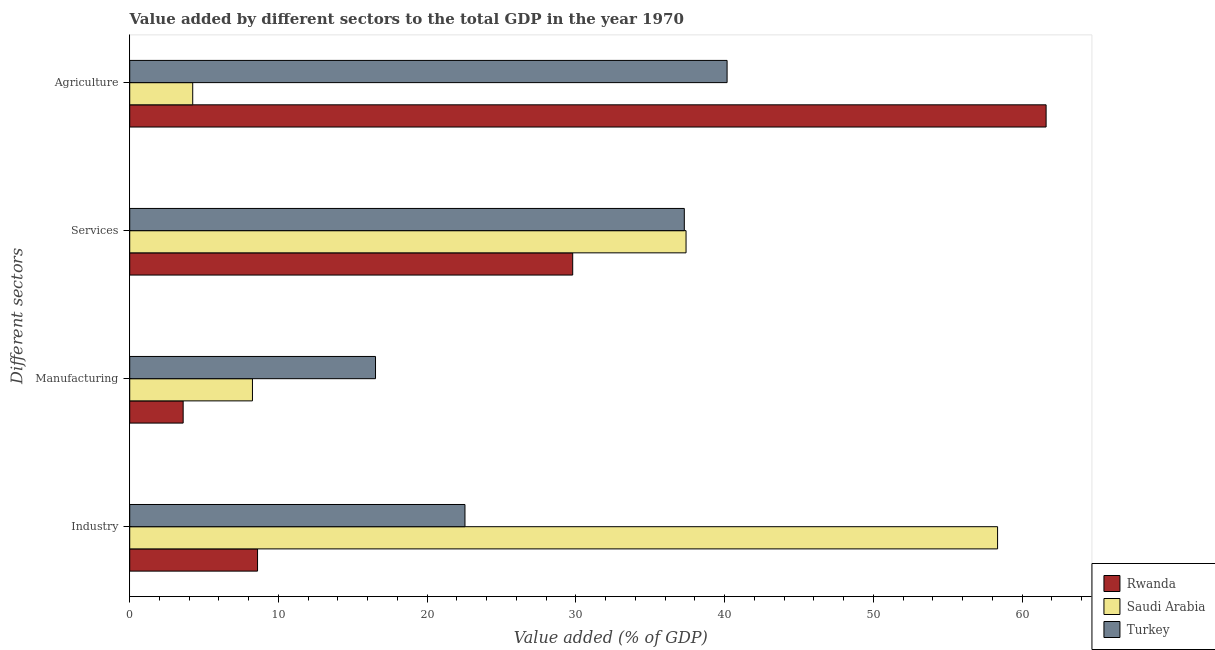How many different coloured bars are there?
Provide a succinct answer. 3. Are the number of bars per tick equal to the number of legend labels?
Make the answer very short. Yes. How many bars are there on the 1st tick from the top?
Provide a short and direct response. 3. What is the label of the 4th group of bars from the top?
Make the answer very short. Industry. What is the value added by industrial sector in Saudi Arabia?
Offer a terse response. 58.36. Across all countries, what is the maximum value added by agricultural sector?
Keep it short and to the point. 61.62. Across all countries, what is the minimum value added by agricultural sector?
Offer a terse response. 4.24. In which country was the value added by industrial sector maximum?
Give a very brief answer. Saudi Arabia. In which country was the value added by industrial sector minimum?
Make the answer very short. Rwanda. What is the total value added by agricultural sector in the graph?
Give a very brief answer. 106.02. What is the difference between the value added by agricultural sector in Turkey and that in Rwanda?
Your response must be concise. -21.45. What is the difference between the value added by manufacturing sector in Rwanda and the value added by industrial sector in Turkey?
Provide a succinct answer. -18.95. What is the average value added by agricultural sector per country?
Your response must be concise. 35.34. What is the difference between the value added by manufacturing sector and value added by agricultural sector in Turkey?
Your answer should be very brief. -23.64. In how many countries, is the value added by agricultural sector greater than 34 %?
Provide a succinct answer. 2. What is the ratio of the value added by industrial sector in Saudi Arabia to that in Turkey?
Offer a very short reply. 2.59. Is the value added by agricultural sector in Saudi Arabia less than that in Turkey?
Your answer should be very brief. Yes. Is the difference between the value added by industrial sector in Saudi Arabia and Rwanda greater than the difference between the value added by agricultural sector in Saudi Arabia and Rwanda?
Keep it short and to the point. Yes. What is the difference between the highest and the second highest value added by agricultural sector?
Keep it short and to the point. 21.45. What is the difference between the highest and the lowest value added by services sector?
Ensure brevity in your answer.  7.62. Is the sum of the value added by agricultural sector in Saudi Arabia and Turkey greater than the maximum value added by manufacturing sector across all countries?
Make the answer very short. Yes. Is it the case that in every country, the sum of the value added by services sector and value added by manufacturing sector is greater than the sum of value added by industrial sector and value added by agricultural sector?
Offer a terse response. No. What does the 3rd bar from the top in Industry represents?
Your answer should be compact. Rwanda. What does the 1st bar from the bottom in Agriculture represents?
Provide a short and direct response. Rwanda. Is it the case that in every country, the sum of the value added by industrial sector and value added by manufacturing sector is greater than the value added by services sector?
Keep it short and to the point. No. How many bars are there?
Make the answer very short. 12. Are the values on the major ticks of X-axis written in scientific E-notation?
Give a very brief answer. No. Does the graph contain grids?
Keep it short and to the point. No. Where does the legend appear in the graph?
Offer a very short reply. Bottom right. What is the title of the graph?
Your answer should be very brief. Value added by different sectors to the total GDP in the year 1970. What is the label or title of the X-axis?
Your response must be concise. Value added (% of GDP). What is the label or title of the Y-axis?
Provide a short and direct response. Different sectors. What is the Value added (% of GDP) in Rwanda in Industry?
Keep it short and to the point. 8.59. What is the Value added (% of GDP) in Saudi Arabia in Industry?
Ensure brevity in your answer.  58.36. What is the Value added (% of GDP) of Turkey in Industry?
Give a very brief answer. 22.54. What is the Value added (% of GDP) in Rwanda in Manufacturing?
Your response must be concise. 3.59. What is the Value added (% of GDP) in Saudi Arabia in Manufacturing?
Give a very brief answer. 8.25. What is the Value added (% of GDP) of Turkey in Manufacturing?
Provide a succinct answer. 16.53. What is the Value added (% of GDP) in Rwanda in Services?
Make the answer very short. 29.79. What is the Value added (% of GDP) in Saudi Arabia in Services?
Ensure brevity in your answer.  37.41. What is the Value added (% of GDP) of Turkey in Services?
Keep it short and to the point. 37.29. What is the Value added (% of GDP) in Rwanda in Agriculture?
Offer a terse response. 61.62. What is the Value added (% of GDP) of Saudi Arabia in Agriculture?
Provide a succinct answer. 4.24. What is the Value added (% of GDP) in Turkey in Agriculture?
Provide a succinct answer. 40.17. Across all Different sectors, what is the maximum Value added (% of GDP) of Rwanda?
Provide a short and direct response. 61.62. Across all Different sectors, what is the maximum Value added (% of GDP) of Saudi Arabia?
Your answer should be very brief. 58.36. Across all Different sectors, what is the maximum Value added (% of GDP) in Turkey?
Your response must be concise. 40.17. Across all Different sectors, what is the minimum Value added (% of GDP) of Rwanda?
Make the answer very short. 3.59. Across all Different sectors, what is the minimum Value added (% of GDP) in Saudi Arabia?
Give a very brief answer. 4.24. Across all Different sectors, what is the minimum Value added (% of GDP) in Turkey?
Make the answer very short. 16.53. What is the total Value added (% of GDP) in Rwanda in the graph?
Your response must be concise. 103.59. What is the total Value added (% of GDP) of Saudi Arabia in the graph?
Offer a terse response. 108.25. What is the total Value added (% of GDP) in Turkey in the graph?
Provide a succinct answer. 116.53. What is the difference between the Value added (% of GDP) in Rwanda in Industry and that in Manufacturing?
Your response must be concise. 5. What is the difference between the Value added (% of GDP) in Saudi Arabia in Industry and that in Manufacturing?
Your answer should be compact. 50.1. What is the difference between the Value added (% of GDP) of Turkey in Industry and that in Manufacturing?
Your answer should be very brief. 6.01. What is the difference between the Value added (% of GDP) of Rwanda in Industry and that in Services?
Make the answer very short. -21.19. What is the difference between the Value added (% of GDP) of Saudi Arabia in Industry and that in Services?
Make the answer very short. 20.95. What is the difference between the Value added (% of GDP) of Turkey in Industry and that in Services?
Offer a terse response. -14.75. What is the difference between the Value added (% of GDP) of Rwanda in Industry and that in Agriculture?
Ensure brevity in your answer.  -53.02. What is the difference between the Value added (% of GDP) in Saudi Arabia in Industry and that in Agriculture?
Your answer should be very brief. 54.12. What is the difference between the Value added (% of GDP) of Turkey in Industry and that in Agriculture?
Make the answer very short. -17.63. What is the difference between the Value added (% of GDP) of Rwanda in Manufacturing and that in Services?
Offer a terse response. -26.19. What is the difference between the Value added (% of GDP) in Saudi Arabia in Manufacturing and that in Services?
Give a very brief answer. -29.16. What is the difference between the Value added (% of GDP) in Turkey in Manufacturing and that in Services?
Give a very brief answer. -20.76. What is the difference between the Value added (% of GDP) of Rwanda in Manufacturing and that in Agriculture?
Keep it short and to the point. -58.03. What is the difference between the Value added (% of GDP) in Saudi Arabia in Manufacturing and that in Agriculture?
Make the answer very short. 4.02. What is the difference between the Value added (% of GDP) of Turkey in Manufacturing and that in Agriculture?
Your response must be concise. -23.64. What is the difference between the Value added (% of GDP) in Rwanda in Services and that in Agriculture?
Provide a short and direct response. -31.83. What is the difference between the Value added (% of GDP) of Saudi Arabia in Services and that in Agriculture?
Your response must be concise. 33.17. What is the difference between the Value added (% of GDP) in Turkey in Services and that in Agriculture?
Provide a short and direct response. -2.88. What is the difference between the Value added (% of GDP) in Rwanda in Industry and the Value added (% of GDP) in Saudi Arabia in Manufacturing?
Your response must be concise. 0.34. What is the difference between the Value added (% of GDP) in Rwanda in Industry and the Value added (% of GDP) in Turkey in Manufacturing?
Your answer should be very brief. -7.93. What is the difference between the Value added (% of GDP) of Saudi Arabia in Industry and the Value added (% of GDP) of Turkey in Manufacturing?
Provide a short and direct response. 41.83. What is the difference between the Value added (% of GDP) in Rwanda in Industry and the Value added (% of GDP) in Saudi Arabia in Services?
Your answer should be compact. -28.81. What is the difference between the Value added (% of GDP) of Rwanda in Industry and the Value added (% of GDP) of Turkey in Services?
Your response must be concise. -28.7. What is the difference between the Value added (% of GDP) of Saudi Arabia in Industry and the Value added (% of GDP) of Turkey in Services?
Offer a terse response. 21.07. What is the difference between the Value added (% of GDP) of Rwanda in Industry and the Value added (% of GDP) of Saudi Arabia in Agriculture?
Make the answer very short. 4.36. What is the difference between the Value added (% of GDP) in Rwanda in Industry and the Value added (% of GDP) in Turkey in Agriculture?
Your answer should be very brief. -31.57. What is the difference between the Value added (% of GDP) of Saudi Arabia in Industry and the Value added (% of GDP) of Turkey in Agriculture?
Provide a short and direct response. 18.19. What is the difference between the Value added (% of GDP) of Rwanda in Manufacturing and the Value added (% of GDP) of Saudi Arabia in Services?
Offer a very short reply. -33.82. What is the difference between the Value added (% of GDP) of Rwanda in Manufacturing and the Value added (% of GDP) of Turkey in Services?
Keep it short and to the point. -33.7. What is the difference between the Value added (% of GDP) in Saudi Arabia in Manufacturing and the Value added (% of GDP) in Turkey in Services?
Your response must be concise. -29.04. What is the difference between the Value added (% of GDP) in Rwanda in Manufacturing and the Value added (% of GDP) in Saudi Arabia in Agriculture?
Provide a short and direct response. -0.64. What is the difference between the Value added (% of GDP) of Rwanda in Manufacturing and the Value added (% of GDP) of Turkey in Agriculture?
Your answer should be very brief. -36.57. What is the difference between the Value added (% of GDP) of Saudi Arabia in Manufacturing and the Value added (% of GDP) of Turkey in Agriculture?
Keep it short and to the point. -31.91. What is the difference between the Value added (% of GDP) of Rwanda in Services and the Value added (% of GDP) of Saudi Arabia in Agriculture?
Give a very brief answer. 25.55. What is the difference between the Value added (% of GDP) in Rwanda in Services and the Value added (% of GDP) in Turkey in Agriculture?
Provide a short and direct response. -10.38. What is the difference between the Value added (% of GDP) in Saudi Arabia in Services and the Value added (% of GDP) in Turkey in Agriculture?
Your response must be concise. -2.76. What is the average Value added (% of GDP) in Rwanda per Different sectors?
Offer a terse response. 25.9. What is the average Value added (% of GDP) of Saudi Arabia per Different sectors?
Make the answer very short. 27.06. What is the average Value added (% of GDP) in Turkey per Different sectors?
Keep it short and to the point. 29.13. What is the difference between the Value added (% of GDP) of Rwanda and Value added (% of GDP) of Saudi Arabia in Industry?
Give a very brief answer. -49.76. What is the difference between the Value added (% of GDP) in Rwanda and Value added (% of GDP) in Turkey in Industry?
Make the answer very short. -13.95. What is the difference between the Value added (% of GDP) in Saudi Arabia and Value added (% of GDP) in Turkey in Industry?
Your answer should be very brief. 35.81. What is the difference between the Value added (% of GDP) in Rwanda and Value added (% of GDP) in Saudi Arabia in Manufacturing?
Provide a short and direct response. -4.66. What is the difference between the Value added (% of GDP) in Rwanda and Value added (% of GDP) in Turkey in Manufacturing?
Make the answer very short. -12.93. What is the difference between the Value added (% of GDP) of Saudi Arabia and Value added (% of GDP) of Turkey in Manufacturing?
Your answer should be compact. -8.27. What is the difference between the Value added (% of GDP) of Rwanda and Value added (% of GDP) of Saudi Arabia in Services?
Give a very brief answer. -7.62. What is the difference between the Value added (% of GDP) of Rwanda and Value added (% of GDP) of Turkey in Services?
Make the answer very short. -7.5. What is the difference between the Value added (% of GDP) in Saudi Arabia and Value added (% of GDP) in Turkey in Services?
Provide a short and direct response. 0.12. What is the difference between the Value added (% of GDP) in Rwanda and Value added (% of GDP) in Saudi Arabia in Agriculture?
Your answer should be compact. 57.38. What is the difference between the Value added (% of GDP) of Rwanda and Value added (% of GDP) of Turkey in Agriculture?
Ensure brevity in your answer.  21.45. What is the difference between the Value added (% of GDP) in Saudi Arabia and Value added (% of GDP) in Turkey in Agriculture?
Provide a short and direct response. -35.93. What is the ratio of the Value added (% of GDP) in Rwanda in Industry to that in Manufacturing?
Your answer should be compact. 2.39. What is the ratio of the Value added (% of GDP) in Saudi Arabia in Industry to that in Manufacturing?
Ensure brevity in your answer.  7.07. What is the ratio of the Value added (% of GDP) of Turkey in Industry to that in Manufacturing?
Provide a short and direct response. 1.36. What is the ratio of the Value added (% of GDP) in Rwanda in Industry to that in Services?
Ensure brevity in your answer.  0.29. What is the ratio of the Value added (% of GDP) in Saudi Arabia in Industry to that in Services?
Your answer should be compact. 1.56. What is the ratio of the Value added (% of GDP) of Turkey in Industry to that in Services?
Your answer should be compact. 0.6. What is the ratio of the Value added (% of GDP) of Rwanda in Industry to that in Agriculture?
Keep it short and to the point. 0.14. What is the ratio of the Value added (% of GDP) in Saudi Arabia in Industry to that in Agriculture?
Ensure brevity in your answer.  13.78. What is the ratio of the Value added (% of GDP) in Turkey in Industry to that in Agriculture?
Your answer should be compact. 0.56. What is the ratio of the Value added (% of GDP) in Rwanda in Manufacturing to that in Services?
Keep it short and to the point. 0.12. What is the ratio of the Value added (% of GDP) in Saudi Arabia in Manufacturing to that in Services?
Offer a terse response. 0.22. What is the ratio of the Value added (% of GDP) in Turkey in Manufacturing to that in Services?
Make the answer very short. 0.44. What is the ratio of the Value added (% of GDP) of Rwanda in Manufacturing to that in Agriculture?
Your answer should be very brief. 0.06. What is the ratio of the Value added (% of GDP) of Saudi Arabia in Manufacturing to that in Agriculture?
Provide a succinct answer. 1.95. What is the ratio of the Value added (% of GDP) of Turkey in Manufacturing to that in Agriculture?
Your response must be concise. 0.41. What is the ratio of the Value added (% of GDP) of Rwanda in Services to that in Agriculture?
Make the answer very short. 0.48. What is the ratio of the Value added (% of GDP) of Saudi Arabia in Services to that in Agriculture?
Your answer should be compact. 8.83. What is the ratio of the Value added (% of GDP) in Turkey in Services to that in Agriculture?
Ensure brevity in your answer.  0.93. What is the difference between the highest and the second highest Value added (% of GDP) in Rwanda?
Your response must be concise. 31.83. What is the difference between the highest and the second highest Value added (% of GDP) of Saudi Arabia?
Offer a very short reply. 20.95. What is the difference between the highest and the second highest Value added (% of GDP) in Turkey?
Your response must be concise. 2.88. What is the difference between the highest and the lowest Value added (% of GDP) in Rwanda?
Offer a very short reply. 58.03. What is the difference between the highest and the lowest Value added (% of GDP) in Saudi Arabia?
Your response must be concise. 54.12. What is the difference between the highest and the lowest Value added (% of GDP) of Turkey?
Make the answer very short. 23.64. 